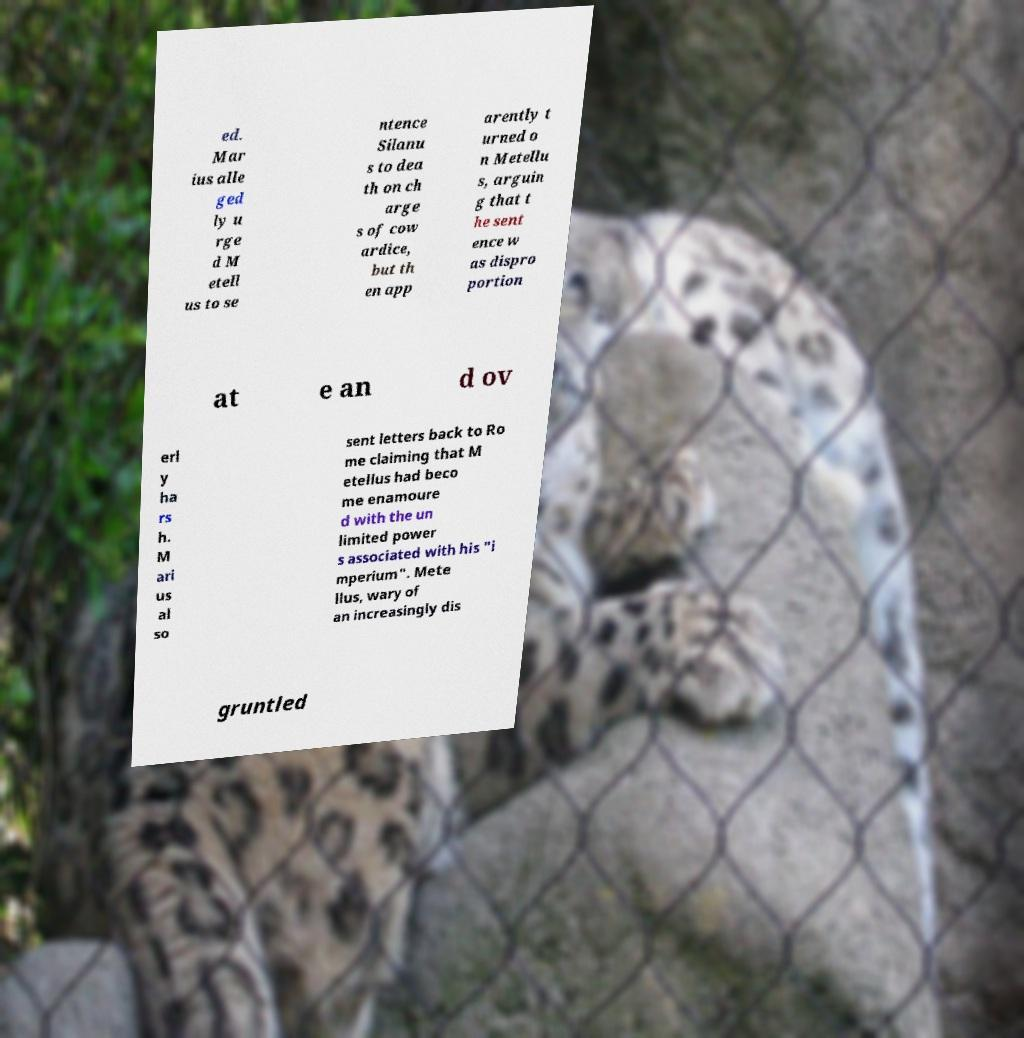What messages or text are displayed in this image? I need them in a readable, typed format. ed. Mar ius alle ged ly u rge d M etell us to se ntence Silanu s to dea th on ch arge s of cow ardice, but th en app arently t urned o n Metellu s, arguin g that t he sent ence w as dispro portion at e an d ov erl y ha rs h. M ari us al so sent letters back to Ro me claiming that M etellus had beco me enamoure d with the un limited power s associated with his "i mperium". Mete llus, wary of an increasingly dis gruntled 